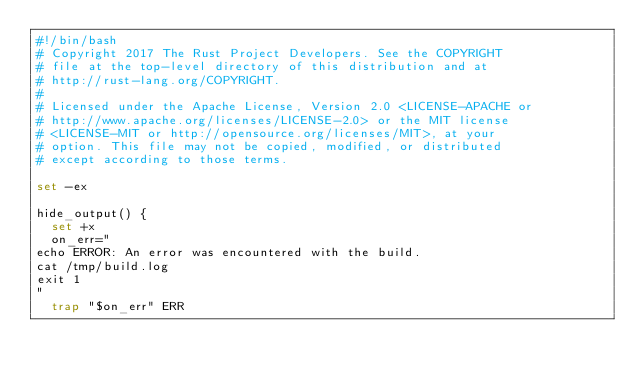Convert code to text. <code><loc_0><loc_0><loc_500><loc_500><_Bash_>#!/bin/bash
# Copyright 2017 The Rust Project Developers. See the COPYRIGHT
# file at the top-level directory of this distribution and at
# http://rust-lang.org/COPYRIGHT.
#
# Licensed under the Apache License, Version 2.0 <LICENSE-APACHE or
# http://www.apache.org/licenses/LICENSE-2.0> or the MIT license
# <LICENSE-MIT or http://opensource.org/licenses/MIT>, at your
# option. This file may not be copied, modified, or distributed
# except according to those terms.

set -ex

hide_output() {
  set +x
  on_err="
echo ERROR: An error was encountered with the build.
cat /tmp/build.log
exit 1
"
  trap "$on_err" ERR</code> 